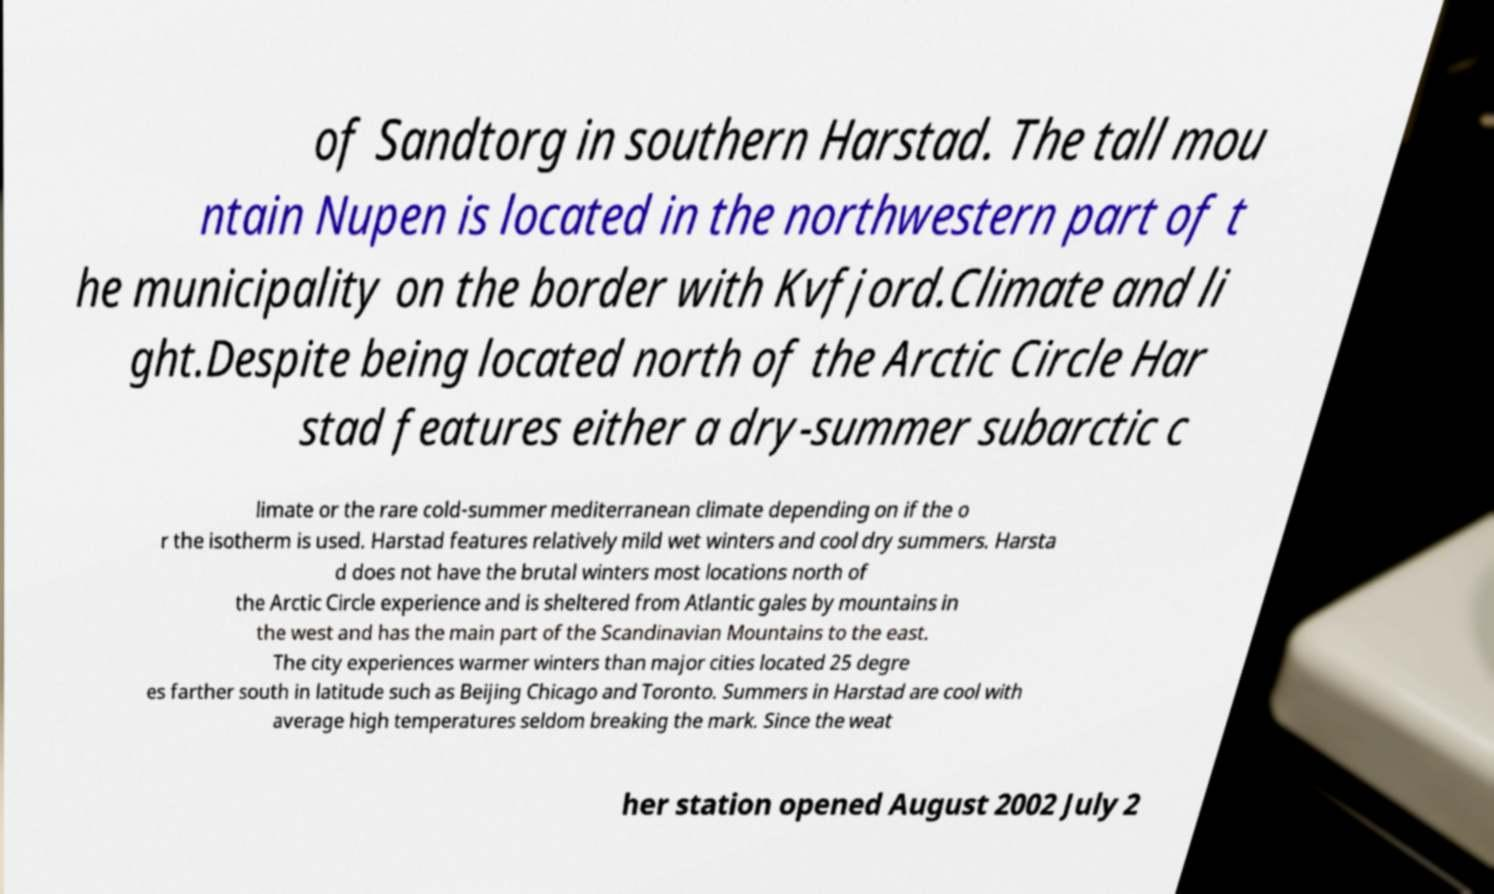Please identify and transcribe the text found in this image. of Sandtorg in southern Harstad. The tall mou ntain Nupen is located in the northwestern part of t he municipality on the border with Kvfjord.Climate and li ght.Despite being located north of the Arctic Circle Har stad features either a dry-summer subarctic c limate or the rare cold-summer mediterranean climate depending on if the o r the isotherm is used. Harstad features relatively mild wet winters and cool dry summers. Harsta d does not have the brutal winters most locations north of the Arctic Circle experience and is sheltered from Atlantic gales by mountains in the west and has the main part of the Scandinavian Mountains to the east. The city experiences warmer winters than major cities located 25 degre es farther south in latitude such as Beijing Chicago and Toronto. Summers in Harstad are cool with average high temperatures seldom breaking the mark. Since the weat her station opened August 2002 July 2 